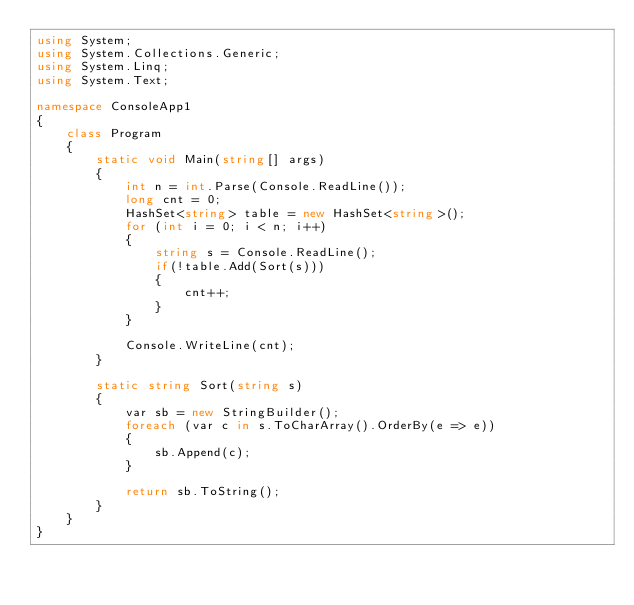Convert code to text. <code><loc_0><loc_0><loc_500><loc_500><_C#_>using System;
using System.Collections.Generic;
using System.Linq;
using System.Text;

namespace ConsoleApp1
{
    class Program
    {
        static void Main(string[] args)
        {
            int n = int.Parse(Console.ReadLine());
            long cnt = 0;
            HashSet<string> table = new HashSet<string>(); 
            for (int i = 0; i < n; i++)
            {
                string s = Console.ReadLine();
                if(!table.Add(Sort(s)))
                {
                    cnt++;
                }
            }

            Console.WriteLine(cnt);
        }

        static string Sort(string s)
        {
            var sb = new StringBuilder();
            foreach (var c in s.ToCharArray().OrderBy(e => e))
            {
                sb.Append(c);
            }

            return sb.ToString();
        }
    }
}
</code> 